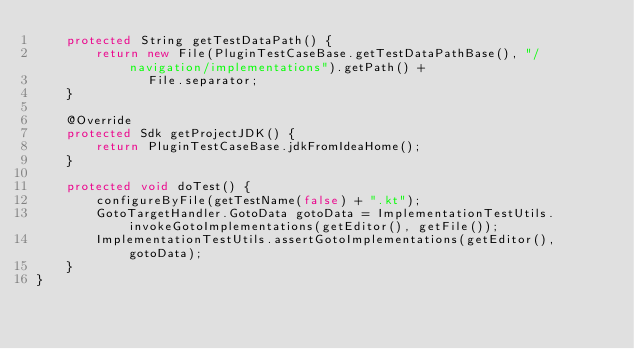Convert code to text. <code><loc_0><loc_0><loc_500><loc_500><_Java_>    protected String getTestDataPath() {
        return new File(PluginTestCaseBase.getTestDataPathBase(), "/navigation/implementations").getPath() +
               File.separator;
    }

    @Override
    protected Sdk getProjectJDK() {
        return PluginTestCaseBase.jdkFromIdeaHome();
    }

    protected void doTest() {
        configureByFile(getTestName(false) + ".kt");
        GotoTargetHandler.GotoData gotoData = ImplementationTestUtils.invokeGotoImplementations(getEditor(), getFile());
        ImplementationTestUtils.assertGotoImplementations(getEditor(), gotoData);
    }
}
</code> 